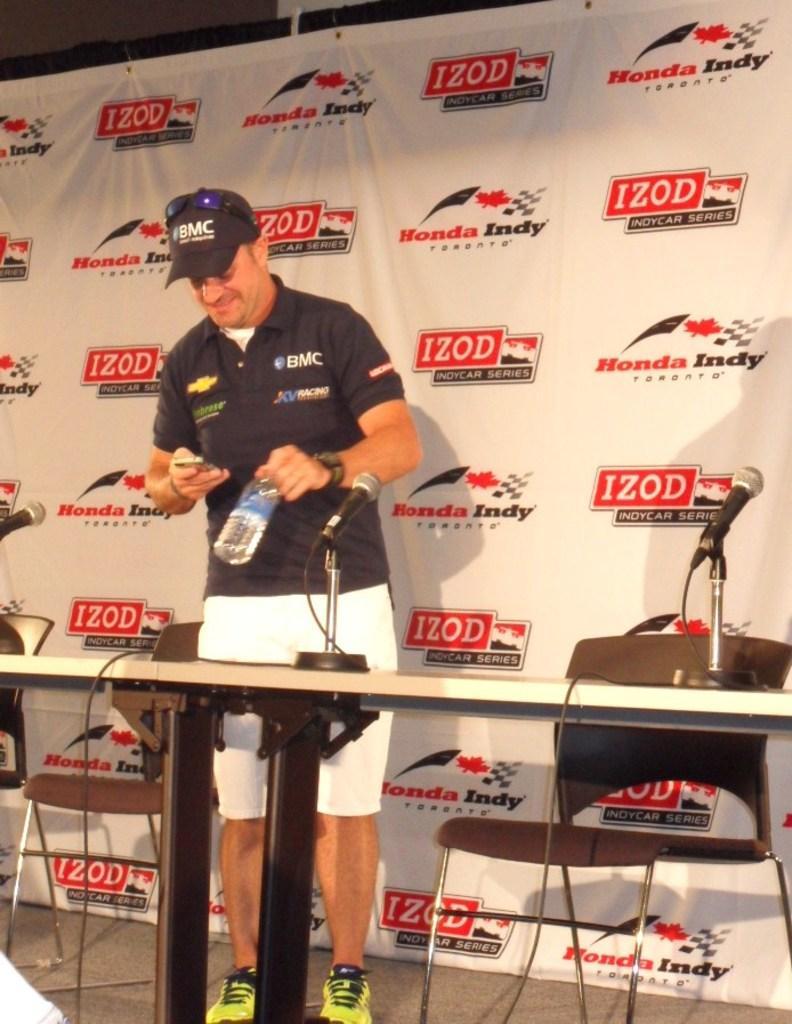Please provide a concise description of this image. In the image we can see a man standing, wearing clothes, shoes, wristwatch, cap and he is smiling. He is holding a bottle in one hand and on the other hand there is a device. Here we can see the table, on the table there are microphones, there are even chairs and poster, on the poster there is a text. 